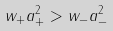Convert formula to latex. <formula><loc_0><loc_0><loc_500><loc_500>w _ { + } a ^ { 2 } _ { + } > w _ { - } a ^ { 2 } _ { - }</formula> 